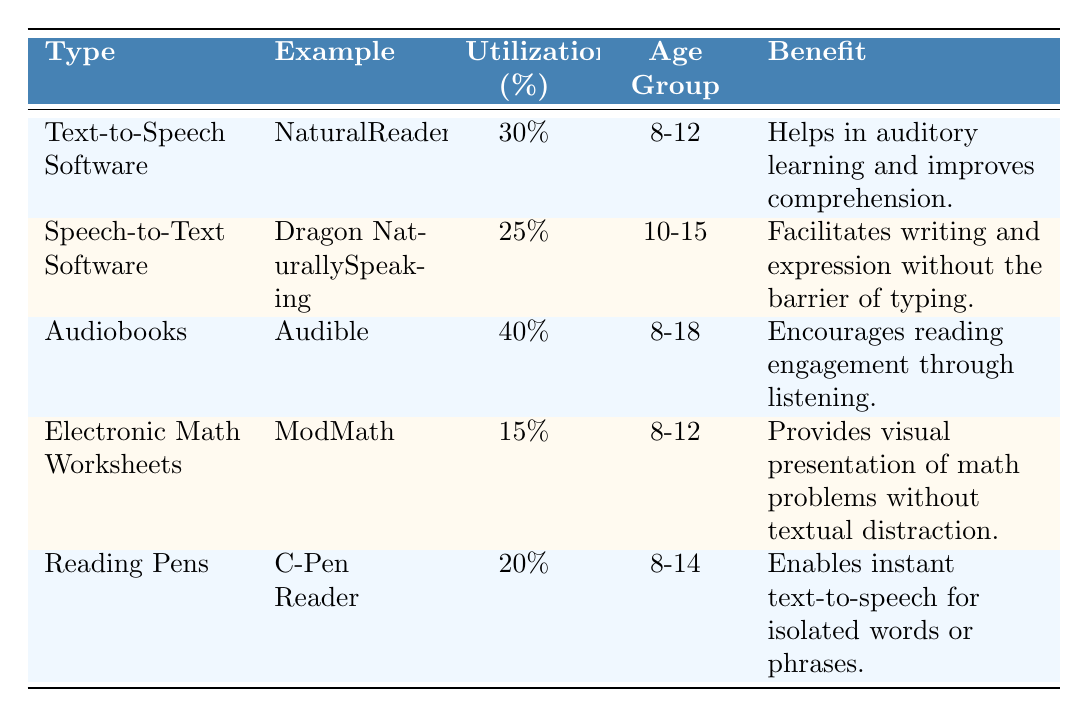What type of assistive technology has the highest utilization percentage? The table shows that Audiobooks have the highest utilization percentage at 40%.
Answer: Audiobooks What is the example of Text-to-Speech Software? According to the table, the example of Text-to-Speech Software is NaturalReader.
Answer: NaturalReader Which assistive technology is targeted at the oldest age group? Looking at the age groups, Audiobooks target the age group 8-18, which is the oldest among all the technologies listed.
Answer: Audiobooks What is the total percentage utilization of the assistive technologies listed? To find the total, we sum the percentages: 30 + 25 + 40 + 15 + 20 = 130%.
Answer: 130% Is the benefit of Reading Pens related to writing? The benefit of Reading Pens is to enable instant text-to-speech for isolated words or phrases, which does not directly relate to writing.
Answer: No Does Audiobooks have a higher utilization percentage than both Reading Pens and Electronic Math Worksheets combined? The individual utilization percentages for Reading Pens (20%) and Electronic Math Worksheets (15%) total 35%, which is lower than Audiobooks' 40%.
Answer: Yes Which assistive technology can be beneficial for auditory learning? The benefit listed for Text-to-Speech Software is that it helps in auditory learning and improves comprehension, making it beneficial for that purpose.
Answer: Text-to-Speech Software Which technology is likely utilized by students aged 10-15? The table indicates that Speech-to-Text Software targets the age group of 10-15, making it suitable for students within that range.
Answer: Speech-to-Text Software What can be inferred about the range of targeted age groups for assistive technologies? By reviewing the age groups, we can see that most technologies (Text-to-Speech, Electronic Math Worksheets, and Reading Pens) target young age groups (8-12 or 8-14), while Audiobooks cater to a broader range (8-18).
Answer: They vary, with some focused on younger students and others on a wider age range 